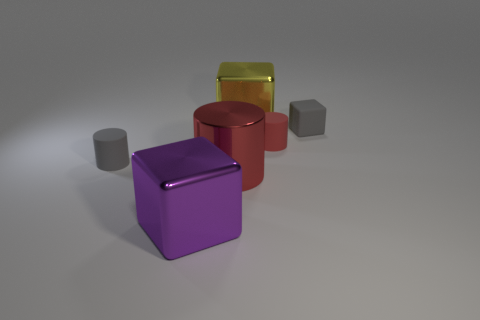There is a tiny gray matte thing in front of the rubber cube; is it the same shape as the gray rubber thing right of the large yellow block?
Offer a terse response. No. What is the shape of the object that is on the left side of the tiny red matte cylinder and behind the small red cylinder?
Your answer should be compact. Cube. There is a purple object that is made of the same material as the large yellow object; what size is it?
Make the answer very short. Large. Is the number of tiny blocks less than the number of big blue rubber cubes?
Provide a short and direct response. No. The tiny cube that is to the right of the big metal block behind the metallic cube that is in front of the red rubber thing is made of what material?
Offer a very short reply. Rubber. Is the small object that is on the left side of the big yellow thing made of the same material as the gray object that is on the right side of the red shiny thing?
Your answer should be very brief. Yes. What size is the metallic object that is both in front of the matte block and behind the large purple object?
Offer a terse response. Large. What is the material of the red cylinder that is the same size as the purple object?
Make the answer very short. Metal. How many large yellow objects are in front of the large metallic object that is behind the matte cylinder that is to the right of the big purple block?
Offer a very short reply. 0. There is a big metal cube behind the gray cylinder; is its color the same as the small matte object to the right of the tiny red matte cylinder?
Your answer should be compact. No. 